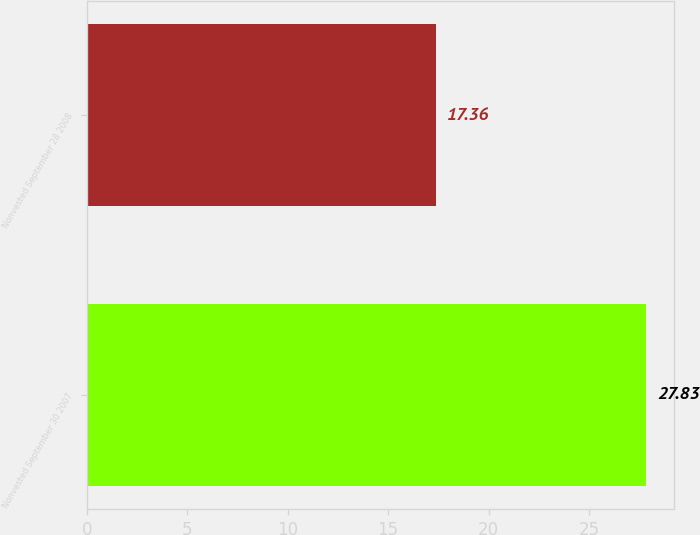Convert chart. <chart><loc_0><loc_0><loc_500><loc_500><bar_chart><fcel>Nonvested September 30 2007<fcel>Nonvested September 28 2008<nl><fcel>27.83<fcel>17.36<nl></chart> 